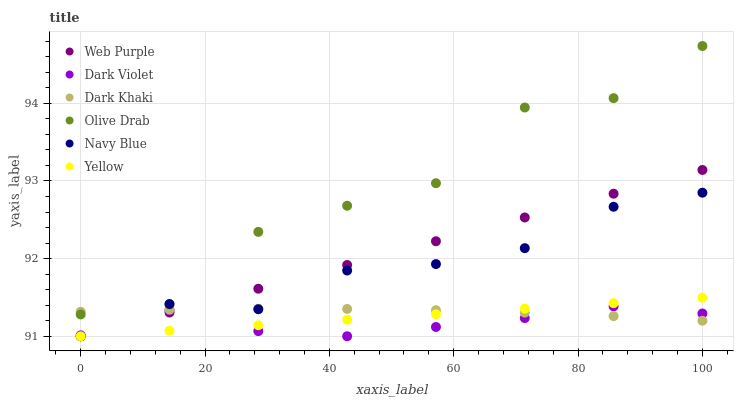Does Dark Violet have the minimum area under the curve?
Answer yes or no. Yes. Does Olive Drab have the maximum area under the curve?
Answer yes or no. Yes. Does Yellow have the minimum area under the curve?
Answer yes or no. No. Does Yellow have the maximum area under the curve?
Answer yes or no. No. Is Web Purple the smoothest?
Answer yes or no. Yes. Is Olive Drab the roughest?
Answer yes or no. Yes. Is Yellow the smoothest?
Answer yes or no. No. Is Yellow the roughest?
Answer yes or no. No. Does Navy Blue have the lowest value?
Answer yes or no. Yes. Does Dark Khaki have the lowest value?
Answer yes or no. No. Does Olive Drab have the highest value?
Answer yes or no. Yes. Does Yellow have the highest value?
Answer yes or no. No. Is Dark Violet less than Olive Drab?
Answer yes or no. Yes. Is Olive Drab greater than Web Purple?
Answer yes or no. Yes. Does Olive Drab intersect Dark Khaki?
Answer yes or no. Yes. Is Olive Drab less than Dark Khaki?
Answer yes or no. No. Is Olive Drab greater than Dark Khaki?
Answer yes or no. No. Does Dark Violet intersect Olive Drab?
Answer yes or no. No. 